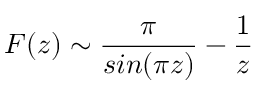<formula> <loc_0><loc_0><loc_500><loc_500>F ( z ) \sim \frac { \pi } { \sin ( \pi z ) } - \frac { 1 } { z }</formula> 